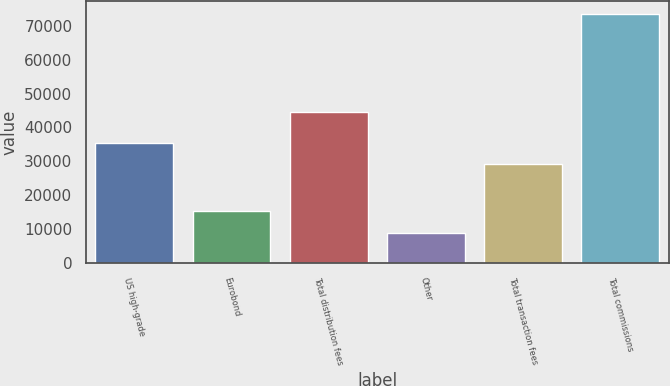Convert chart. <chart><loc_0><loc_0><loc_500><loc_500><bar_chart><fcel>US high-grade<fcel>Eurobond<fcel>Total distribution fees<fcel>Other<fcel>Total transaction fees<fcel>Total commissions<nl><fcel>35567.3<fcel>15304.3<fcel>44430<fcel>8835<fcel>29098<fcel>73528<nl></chart> 